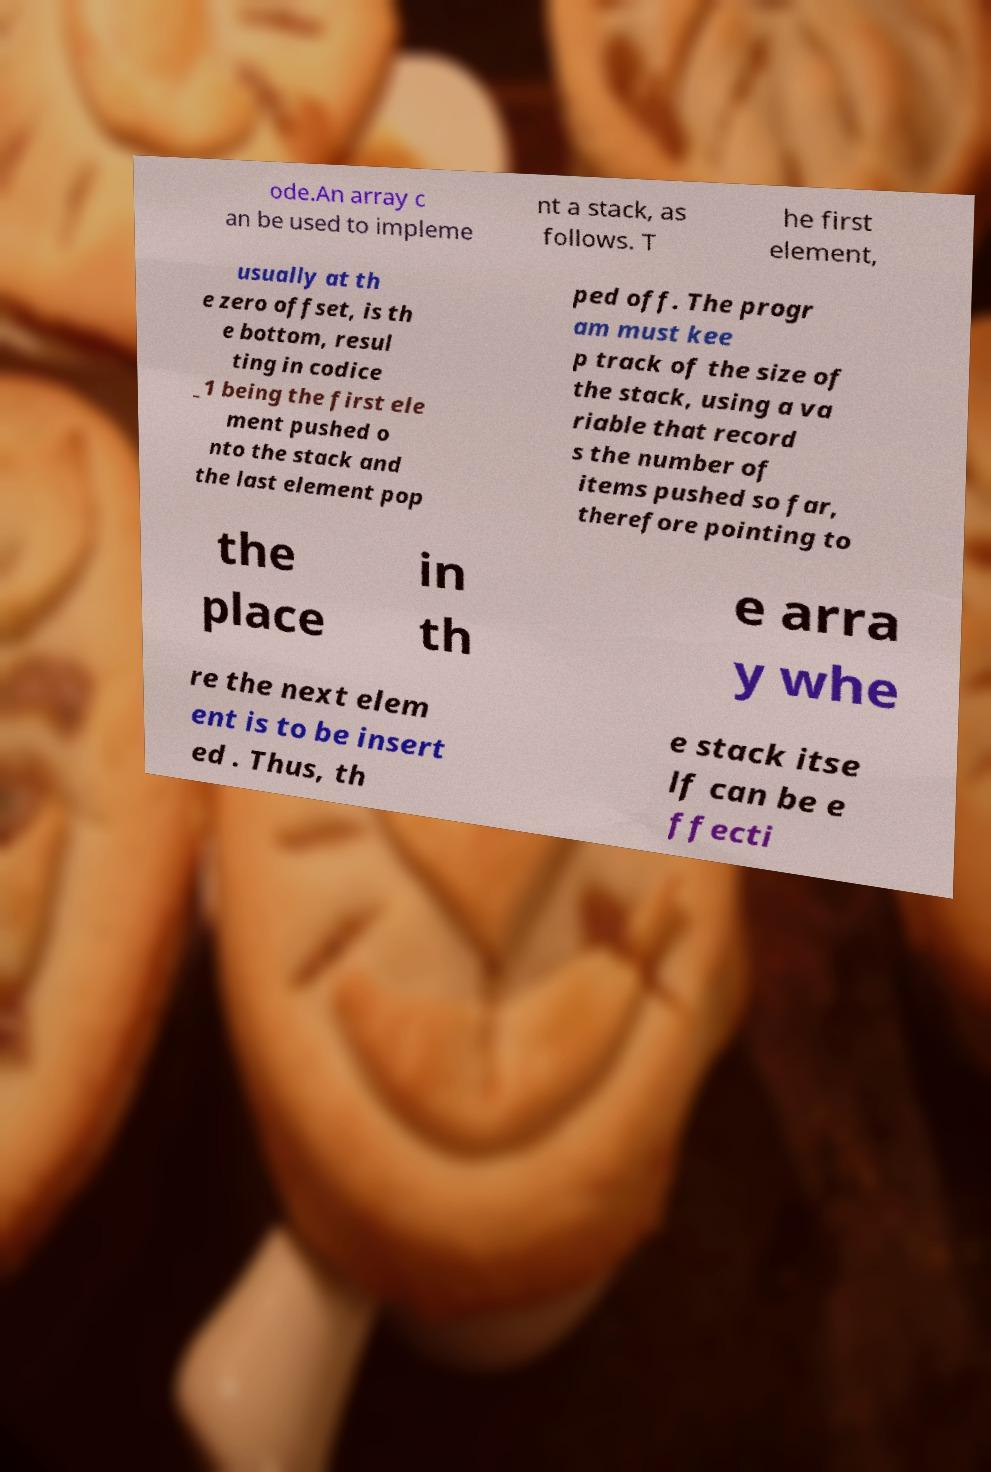Can you read and provide the text displayed in the image?This photo seems to have some interesting text. Can you extract and type it out for me? ode.An array c an be used to impleme nt a stack, as follows. T he first element, usually at th e zero offset, is th e bottom, resul ting in codice _1 being the first ele ment pushed o nto the stack and the last element pop ped off. The progr am must kee p track of the size of the stack, using a va riable that record s the number of items pushed so far, therefore pointing to the place in th e arra y whe re the next elem ent is to be insert ed . Thus, th e stack itse lf can be e ffecti 